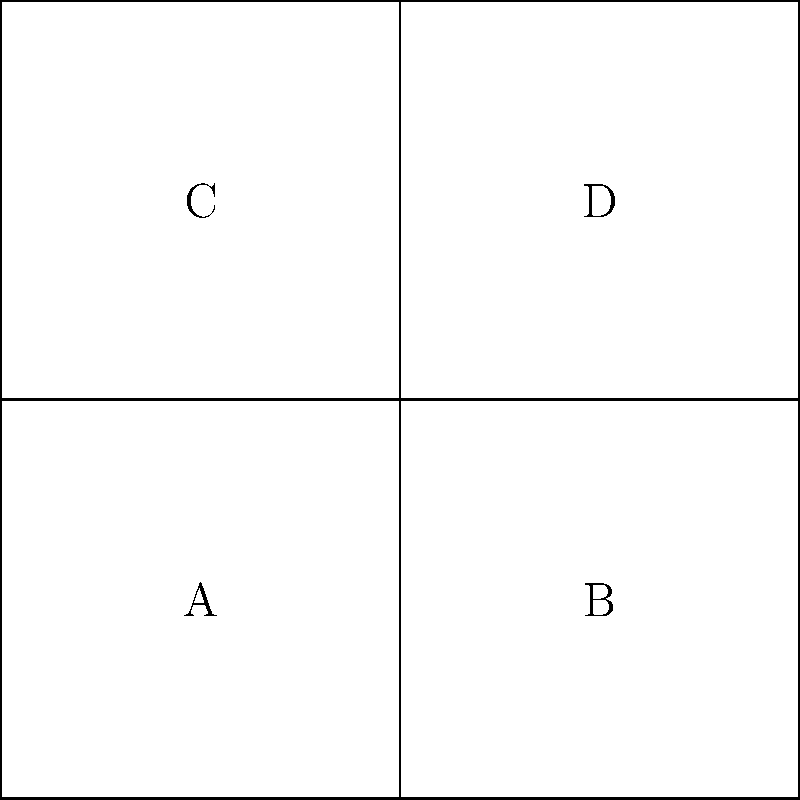While folding laundry, you come across a square cloth napkin. If you were to fold this napkin according to the pattern shown on the left, which 3D shape on the right would it create? Consider how each labeled section (A, B, C, D) would form part of the final shape. Let's approach this step-by-step:

1. First, observe the unfolded shape on the left. It's a cross-shaped pattern made up of four squares labeled A, B, C, and D.

2. The dashed lines indicate where the shape will be folded.

3. When folding, square A will remain stationary as the base.

4. Square B will fold up to form the right side of the cube.

5. Square C will fold up to form the back side of the cube.

6. Square D will fold up to form the top of the cube.

7. The left side and front of the cube will be open, as there are no squares to fold in those directions.

8. Looking at the 3D shape on the right, we can see it's a cube with three visible faces.

9. This matches perfectly with our folded napkin: we have a base (A), a right side (B), a back (C), and a top (D), forming three sides of a cube.

Therefore, the folded napkin would indeed create the cube shape shown on the right.
Answer: Cube 